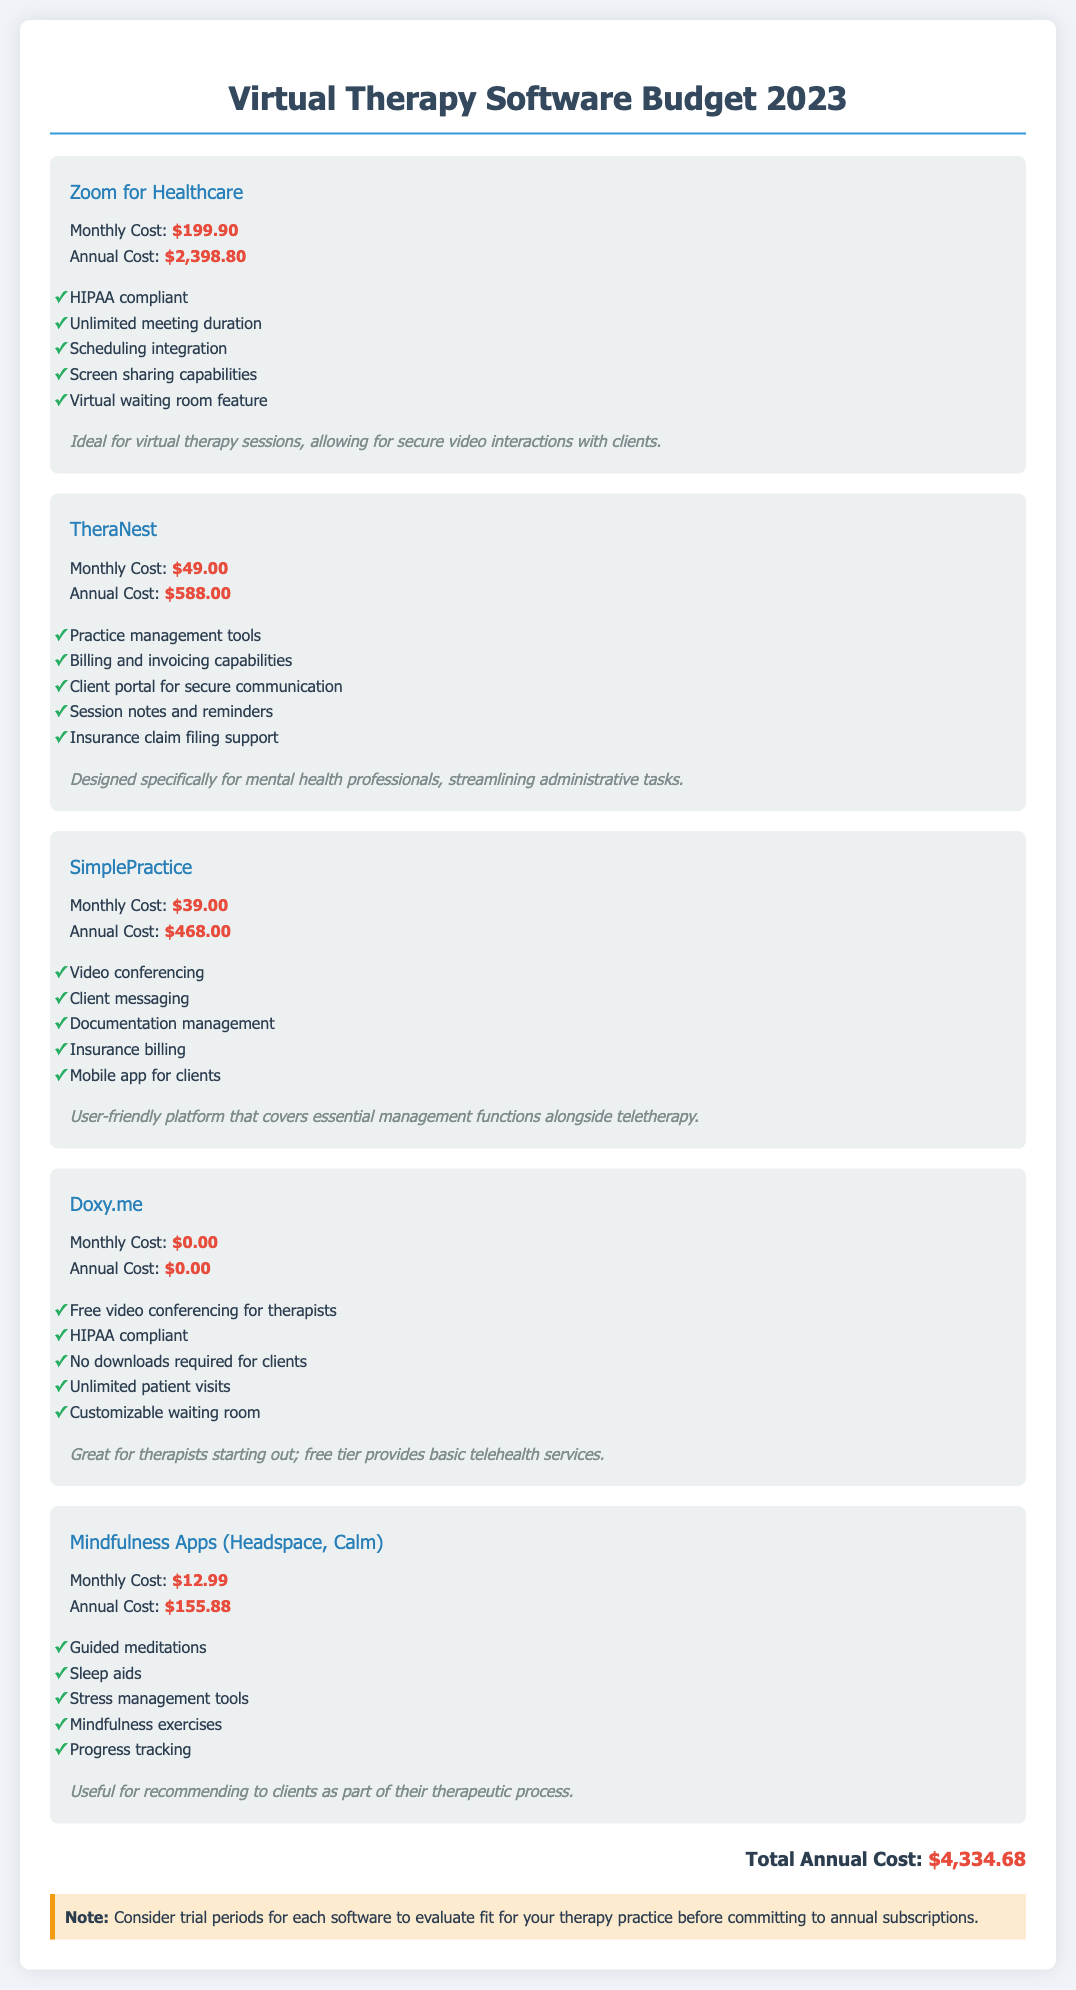what is the total annual cost? The total annual cost is mentioned at the end of the document, summarizing all software expenses.
Answer: $4,334.68 how much does Zoom for Healthcare cost monthly? The document states that the monthly cost of Zoom for Healthcare is listed under its pricing details.
Answer: $199.90 which software offers a free version? Analyzing the listed software, Doxy.me is highlighted for not having any charges associated with it.
Answer: Doxy.me what is one feature of TheraNest? One feature of TheraNest can be found in the list of features provided in the software section.
Answer: Practice management tools how many features does SimplePractice list? The software section for SimplePractice includes a bullet point list that specifies its features.
Answer: Five what is the usage of Mindfulness Apps? The usage is described in a sentence that summarizes the recommendation for client therapy.
Answer: Useful for recommending to clients as part of their therapeutic process what is the monthly cost of Mindfulness Apps? The cost is clearly outlined in the software section for Mindfulness Apps, providing an accessible amount.
Answer: $12.99 what is a feature of Doxy.me? The document lists several features available for Doxy.me, highlighting its functionality.
Answer: HIPAA compliant what is the annual cost of SimplePractice? The annual cost is indicated in the pricing details for SimplePractice within the document.
Answer: $468.00 